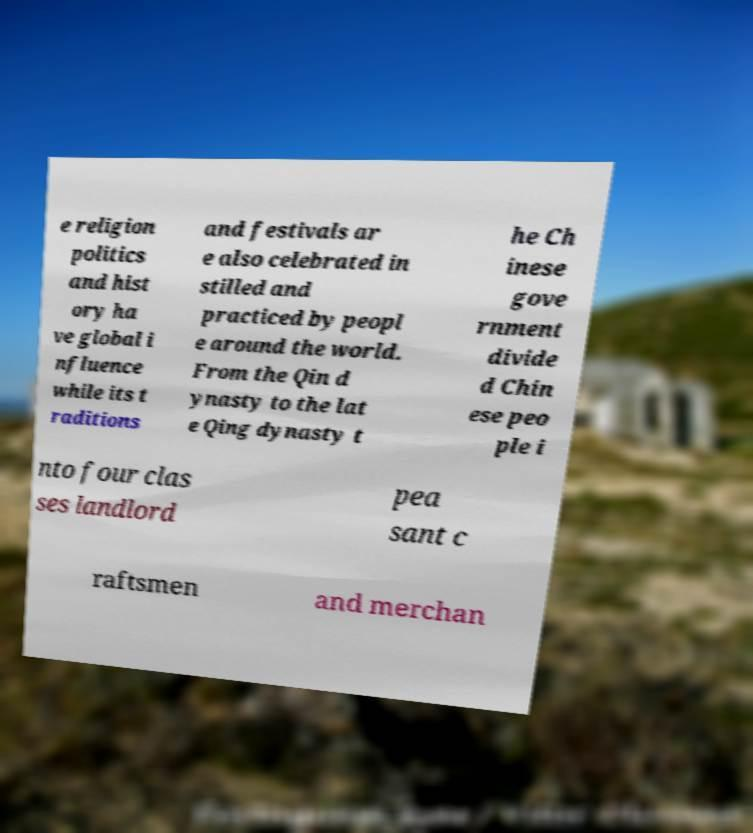Could you extract and type out the text from this image? e religion politics and hist ory ha ve global i nfluence while its t raditions and festivals ar e also celebrated in stilled and practiced by peopl e around the world. From the Qin d ynasty to the lat e Qing dynasty t he Ch inese gove rnment divide d Chin ese peo ple i nto four clas ses landlord pea sant c raftsmen and merchan 